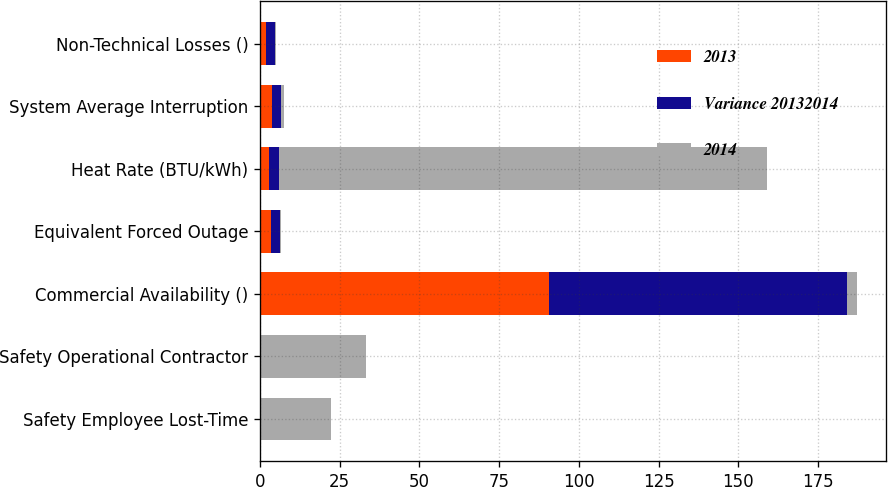<chart> <loc_0><loc_0><loc_500><loc_500><stacked_bar_chart><ecel><fcel>Safety Employee Lost-Time<fcel>Safety Operational Contractor<fcel>Commercial Availability ()<fcel>Equivalent Forced Outage<fcel>Heat Rate (BTU/kWh)<fcel>System Average Interruption<fcel>Non-Technical Losses ()<nl><fcel>2013<fcel>0.08<fcel>0.08<fcel>90.5<fcel>3.29<fcel>2.945<fcel>3.7<fcel>2.03<nl><fcel>Variance 20132014<fcel>0.1<fcel>0.12<fcel>93.55<fcel>2.92<fcel>2.945<fcel>2.97<fcel>2.52<nl><fcel>2014<fcel>22<fcel>33<fcel>3.05<fcel>0.4<fcel>153<fcel>0.73<fcel>0.49<nl></chart> 